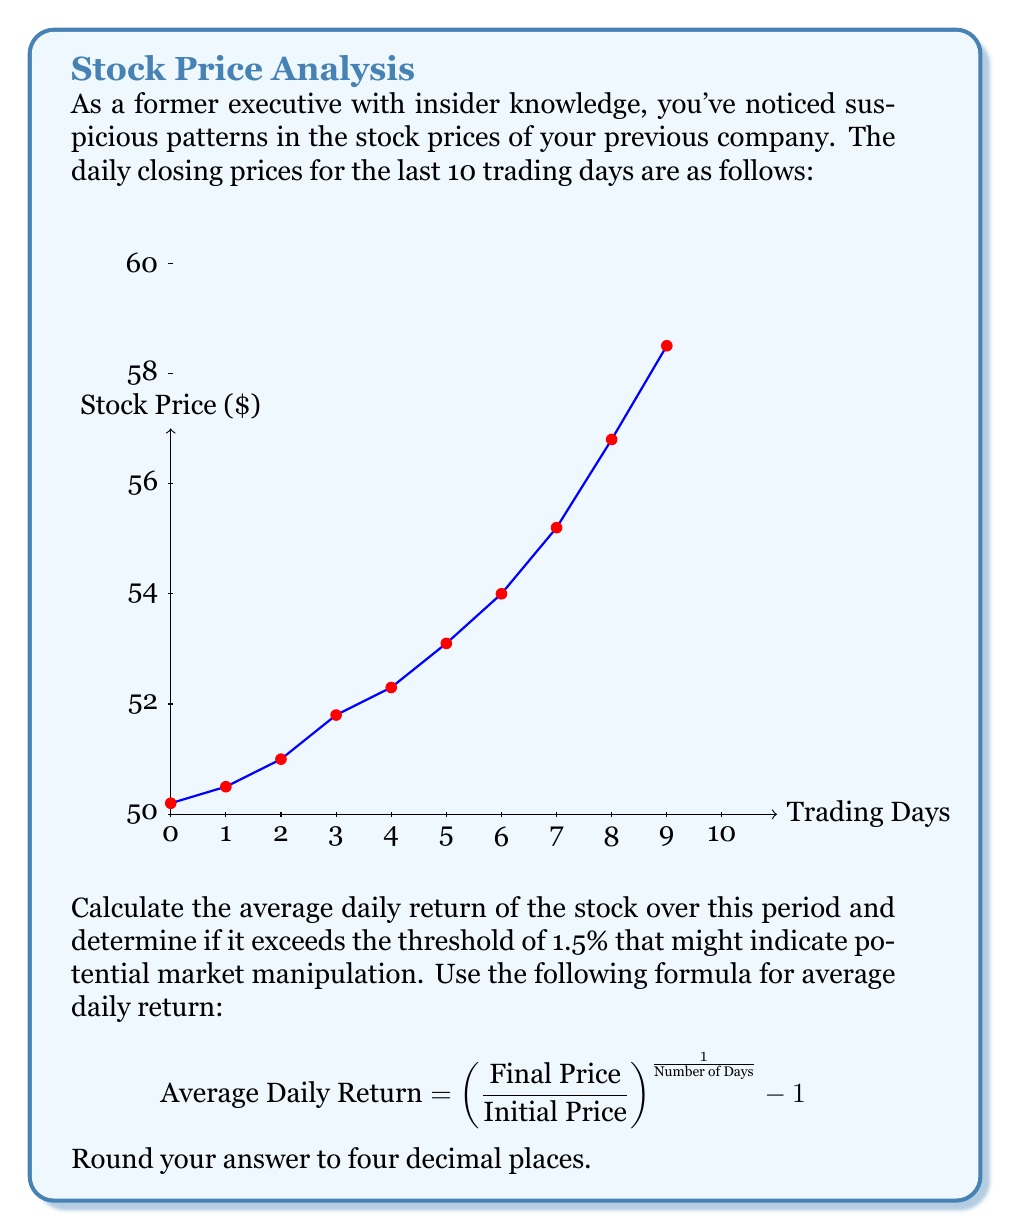Provide a solution to this math problem. Let's approach this step-by-step:

1) First, we need to identify the initial and final prices:
   Initial Price = $50.2
   Final Price = $58.5

2) We have 10 trading days of data.

3) Now, let's plug these values into our formula:

   $$ \text{Average Daily Return} = \left(\frac{58.5}{50.2}\right)^{\frac{1}{10}} - 1 $$

4) Let's solve this step-by-step:
   
   a) First, calculate the ratio inside the parentheses:
      $\frac{58.5}{50.2} = 1.1653386454$
   
   b) Now, we need to take this to the power of $\frac{1}{10}$:
      $1.1653386454^{\frac{1}{10}} = 1.0154470153$
   
   c) Finally, subtract 1:
      $1.0154470153 - 1 = 0.0154470153$

5) Converting to a percentage and rounding to four decimal places:
   $0.0154470153 * 100 = 1.5447\%$

6) Compare this to the threshold of 1.5%:
   $1.5447\% > 1.5\%$

Therefore, the average daily return does exceed the threshold of 1.5%, which might indicate potential market manipulation.
Answer: 1.5447% 